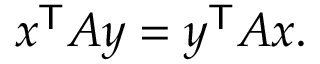<formula> <loc_0><loc_0><loc_500><loc_500>x ^ { T } A y = y ^ { T } A x .</formula> 